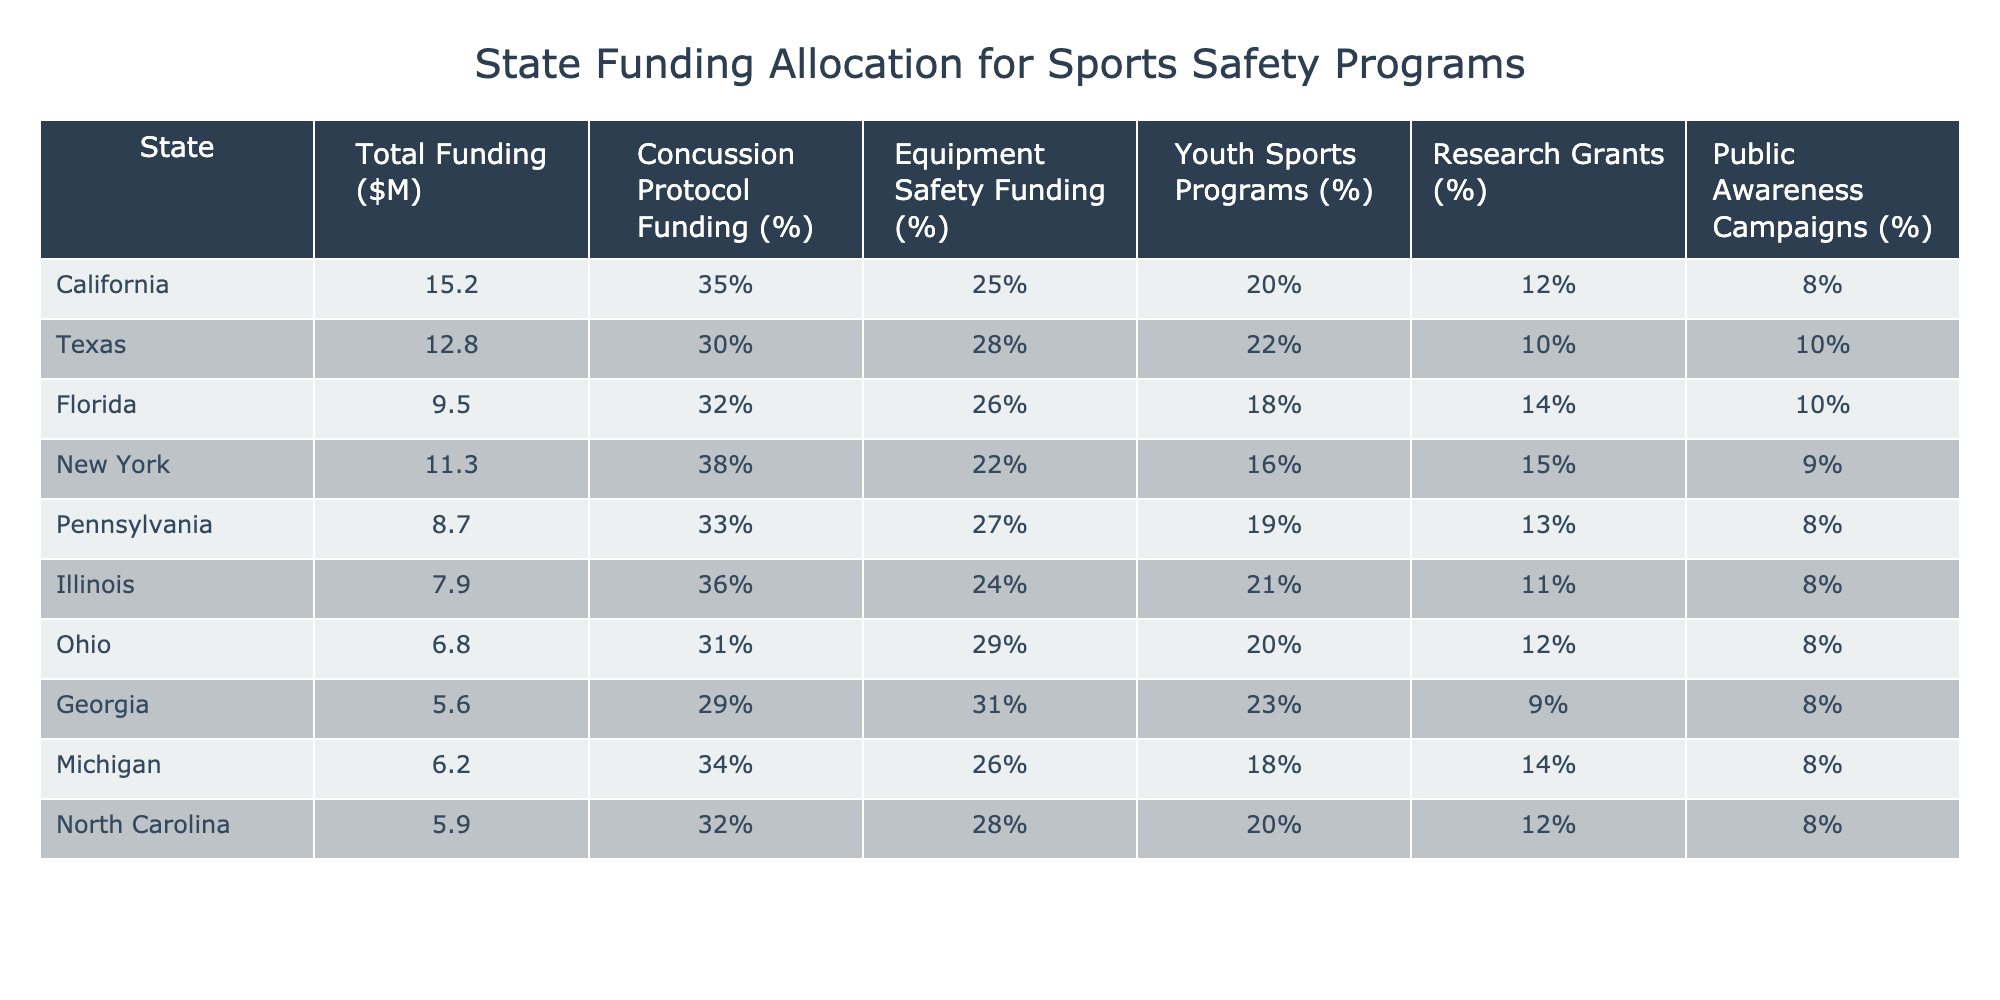What state has the highest total funding allocation for sports safety programs? By looking at the "Total Funding ($M)" column, California has the highest value at 15.2 million dollars.
Answer: California Which state allocates the lowest percentage for concussion protocol funding? The "Concussion Protocol Funding (%)" column shows that Georgia has the lowest allocation at 29%.
Answer: Georgia What is the average percentage allocated to equipment safety across all states? To find the average, sum the equipment safety percentages (25 + 28 + 26 + 22 + 27 + 24 + 29 + 31 + 26 + 28 =  26.6) and divide by 10 (the number of states):  266/10 = 26.6%.
Answer: 26.6% Does Florida allocate more funding for public awareness campaigns than New York? Florida allocates 10% while New York allocates 9%, so Florida allocates more.
Answer: Yes Which state has a greater percentage of funding allocated to youth sports programs: Illinois or Texas? Illinois allocates 21% while Texas allocates 22%, so Texas has a greater allocation.
Answer: Texas What is the total funding allocated for concussion protocol across all states? Calculate the total by summing up the individual allocations: (15.2*0.35 + 12.8*0.30 + 9.5*0.32 + 11.3*0.38 + 8.7*0.33 + 7.9*0.36 + 6.8*0.31 + 5.6*0.29 + 6.2*0.34 + 5.9*0.32), resulting in approximately 9.57 million dollars.
Answer: 9.57 million dollars What percentage of funding does New York allocate to research grants, and how does it compare with the average across all states? New York allocates 15% for research grants, and by calculating the average from the data (sum of research grants percentages divided by 10), the average is 12%. Comparing 15% with 12%, New York allocates more than the average.
Answer: New York allocates more Is the total funding allocated to sports safety programs in Texas more than the combined funding in Georgia and Michigan? Texas has a total funding of 12.8 million dollars, whereas Georgia and Michigan combined have 5.6 + 6.2 = 11.8 million dollars, so Texas has more total funding.
Answer: Yes What state has the closest percentage allocation for youth sports programs to the average percentage across all states? The average for youth sports programs is 20.7%, and upon checking the values, North Carolina allocates 20% which is the closest.
Answer: North Carolina 